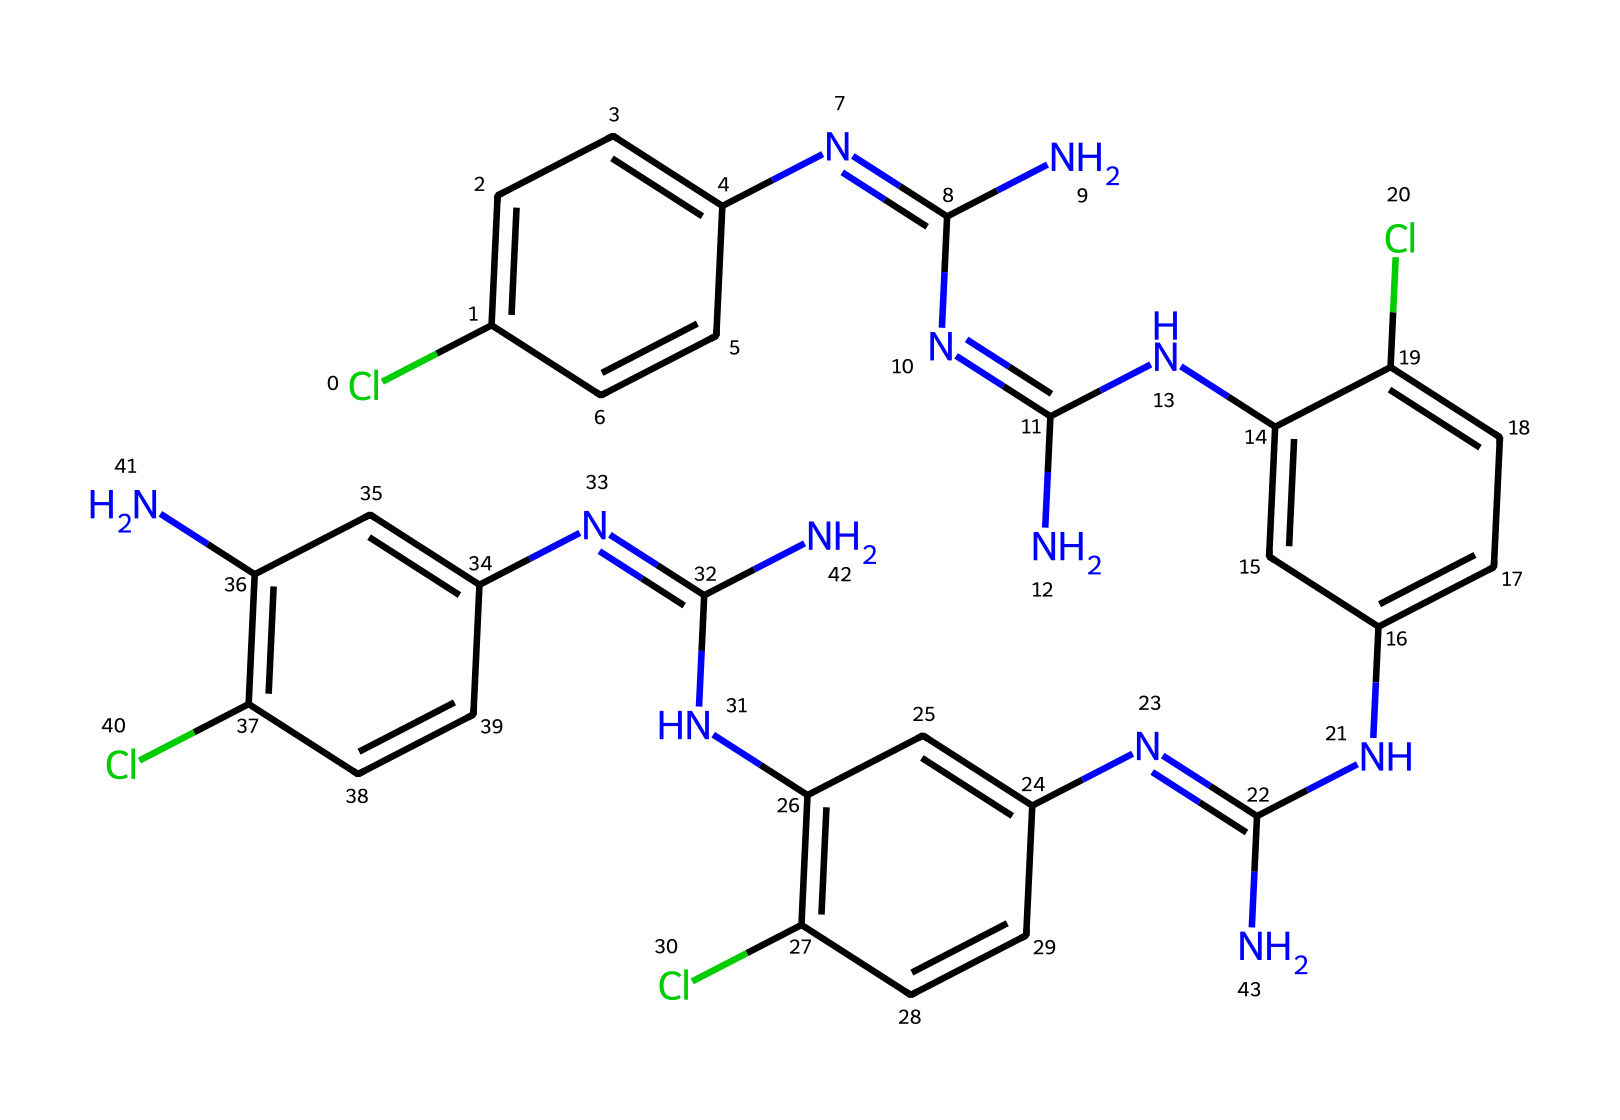What is the main function of chlorhexidine in wound care? Chlorhexidine is primarily an antiseptic, which means it is used to reduce the risk of infection in wounds by killing bacteria.
Answer: antiseptic How many nitrogen atoms are present in chlorhexidine? By visual inspection of the SMILES structure, there are a total of six nitrogen atoms (N) explicitly represented.
Answer: six What type of chemical compound is chlorhexidine classified as? Chlorhexidine is classified as a bisbiguanide, which indicates that it has two guanidine groups linked together, contributing to its function as an antiseptic.
Answer: bisbiguanide What element is represented by 'Cl' in the structure? The 'Cl' represents chlorine, which is commonly known for its antiseptic properties and is used in chlorhexidine.
Answer: chlorine How does chlorhexidine's structure contribute to its antimicrobial properties? Chlorhexidine’s multiple nitrogen atoms likely contribute to positive charge which enhances its ability to bind to and disrupt bacterial cell membranes, leading to its antimicrobial action.
Answer: positive charge What is the total number of aromatic rings in the chlorhexidine structure? The chemical structure has four aromatic rings, identifiable by the presence of multiple alternating double bonds (C=C) within the rings.
Answer: four 